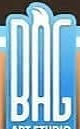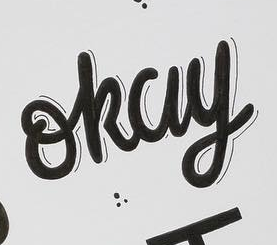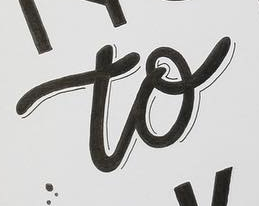What words can you see in these images in sequence, separated by a semicolon? BAG; okay; to 